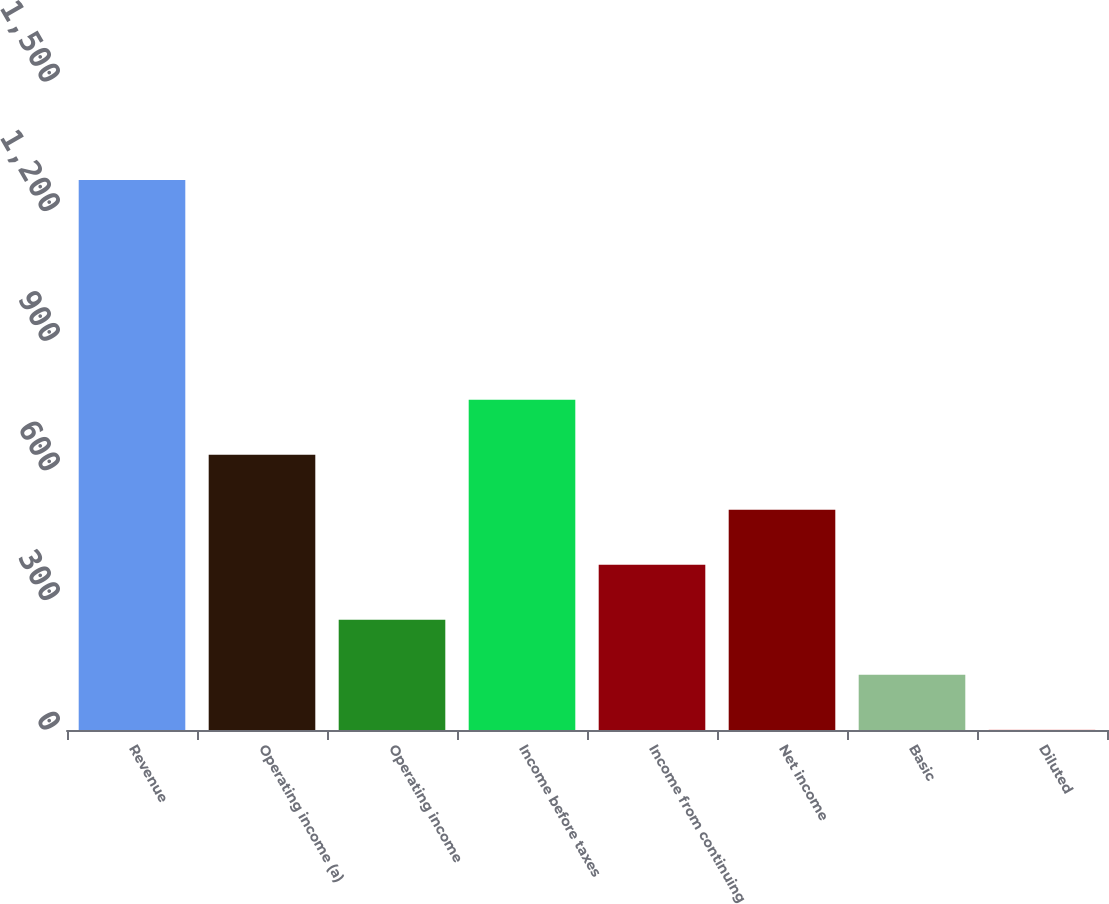Convert chart to OTSL. <chart><loc_0><loc_0><loc_500><loc_500><bar_chart><fcel>Revenue<fcel>Operating income (a)<fcel>Operating income<fcel>Income before taxes<fcel>Income from continuing<fcel>Net income<fcel>Basic<fcel>Diluted<nl><fcel>1273.4<fcel>637.09<fcel>255.28<fcel>764.36<fcel>382.55<fcel>509.82<fcel>128.01<fcel>0.74<nl></chart> 